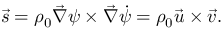<formula> <loc_0><loc_0><loc_500><loc_500>\vec { s } = \rho _ { 0 } \vec { \nabla } \psi \times \vec { \nabla } \dot { \psi } = \rho _ { 0 } \vec { u } \times \vec { v } .</formula> 